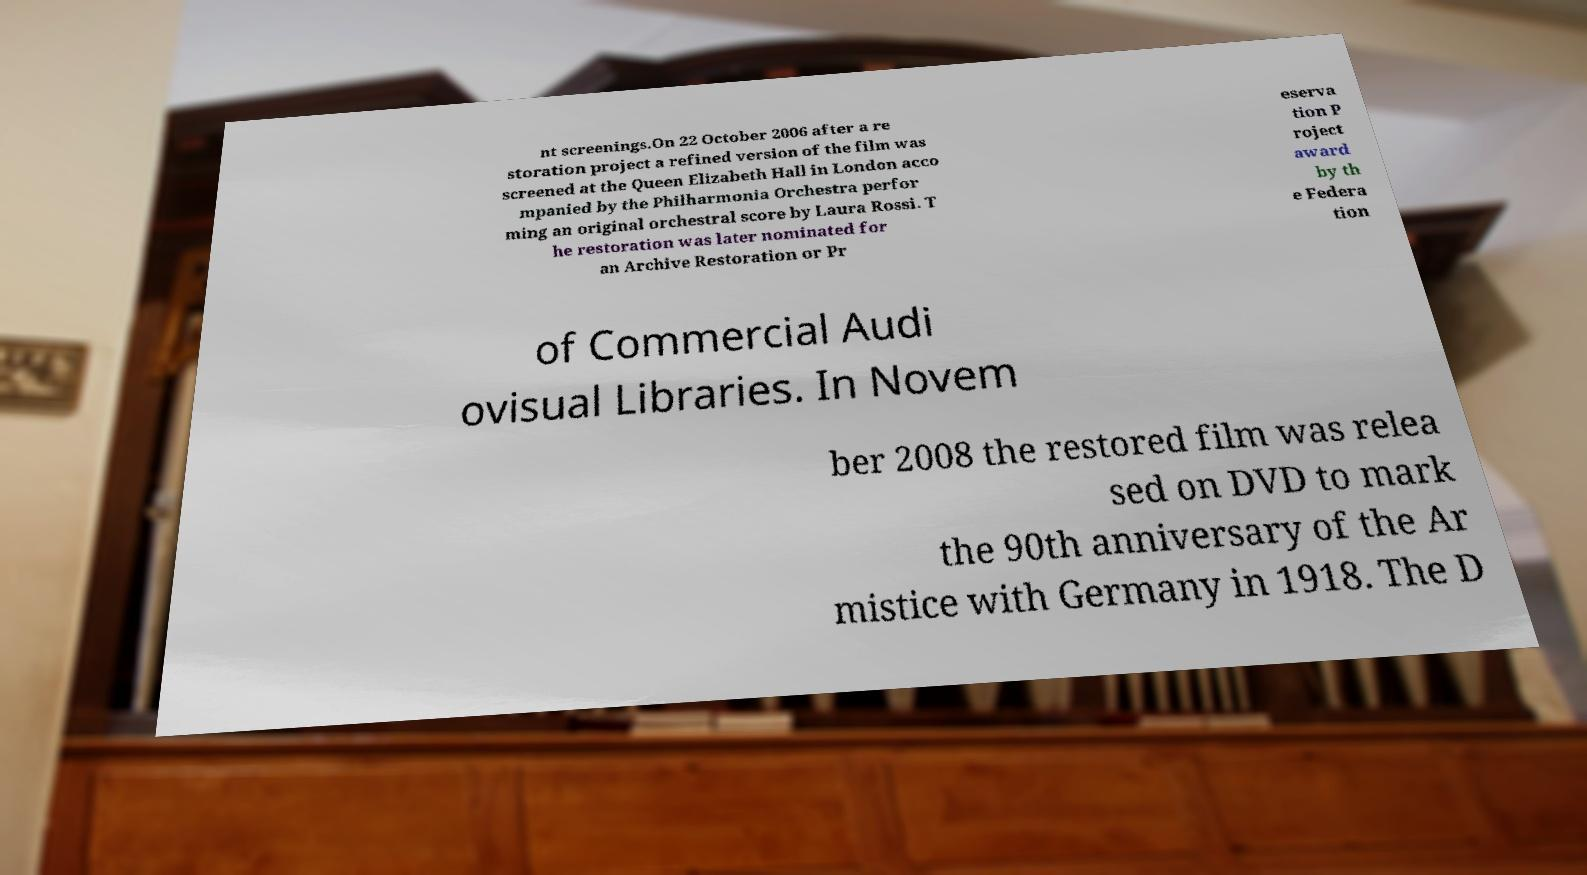Could you extract and type out the text from this image? nt screenings.On 22 October 2006 after a re storation project a refined version of the film was screened at the Queen Elizabeth Hall in London acco mpanied by the Philharmonia Orchestra perfor ming an original orchestral score by Laura Rossi. T he restoration was later nominated for an Archive Restoration or Pr eserva tion P roject award by th e Federa tion of Commercial Audi ovisual Libraries. In Novem ber 2008 the restored film was relea sed on DVD to mark the 90th anniversary of the Ar mistice with Germany in 1918. The D 